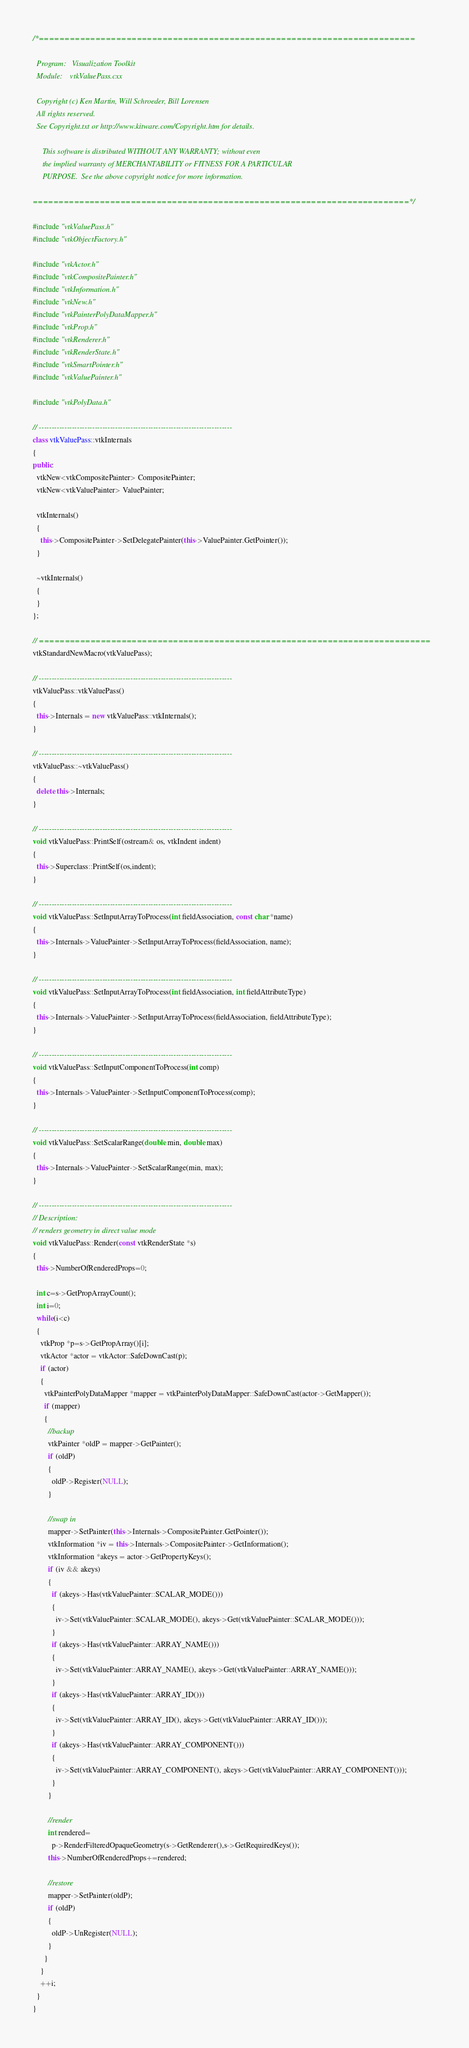<code> <loc_0><loc_0><loc_500><loc_500><_C++_>/*=========================================================================

  Program:   Visualization Toolkit
  Module:    vtkValuePass.cxx

  Copyright (c) Ken Martin, Will Schroeder, Bill Lorensen
  All rights reserved.
  See Copyright.txt or http://www.kitware.com/Copyright.htm for details.

     This software is distributed WITHOUT ANY WARRANTY; without even
     the implied warranty of MERCHANTABILITY or FITNESS FOR A PARTICULAR
     PURPOSE.  See the above copyright notice for more information.

=========================================================================*/

#include "vtkValuePass.h"
#include "vtkObjectFactory.h"

#include "vtkActor.h"
#include "vtkCompositePainter.h"
#include "vtkInformation.h"
#include "vtkNew.h"
#include "vtkPainterPolyDataMapper.h"
#include "vtkProp.h"
#include "vtkRenderer.h"
#include "vtkRenderState.h"
#include "vtkSmartPointer.h"
#include "vtkValuePainter.h"

#include "vtkPolyData.h"

// ----------------------------------------------------------------------------
class vtkValuePass::vtkInternals
{
public:
  vtkNew<vtkCompositePainter> CompositePainter;
  vtkNew<vtkValuePainter> ValuePainter;

  vtkInternals()
  {
    this->CompositePainter->SetDelegatePainter(this->ValuePainter.GetPointer());
  }

  ~vtkInternals()
  {
  }
};

// ============================================================================
vtkStandardNewMacro(vtkValuePass);

// ----------------------------------------------------------------------------
vtkValuePass::vtkValuePass()
{
  this->Internals = new vtkValuePass::vtkInternals();
}

// ----------------------------------------------------------------------------
vtkValuePass::~vtkValuePass()
{
  delete this->Internals;
}

// ----------------------------------------------------------------------------
void vtkValuePass::PrintSelf(ostream& os, vtkIndent indent)
{
  this->Superclass::PrintSelf(os,indent);
}

// ----------------------------------------------------------------------------
void vtkValuePass::SetInputArrayToProcess(int fieldAssociation, const char *name)
{
  this->Internals->ValuePainter->SetInputArrayToProcess(fieldAssociation, name);
}

// ----------------------------------------------------------------------------
void vtkValuePass::SetInputArrayToProcess(int fieldAssociation, int fieldAttributeType)
{
  this->Internals->ValuePainter->SetInputArrayToProcess(fieldAssociation, fieldAttributeType);
}

// ----------------------------------------------------------------------------
void vtkValuePass::SetInputComponentToProcess(int comp)
{
  this->Internals->ValuePainter->SetInputComponentToProcess(comp);
}

// ----------------------------------------------------------------------------
void vtkValuePass::SetScalarRange(double min, double max)
{
  this->Internals->ValuePainter->SetScalarRange(min, max);
}

// ----------------------------------------------------------------------------
// Description:
// renders geometry in direct value mode
void vtkValuePass::Render(const vtkRenderState *s)
{
  this->NumberOfRenderedProps=0;

  int c=s->GetPropArrayCount();
  int i=0;
  while(i<c)
  {
    vtkProp *p=s->GetPropArray()[i];
    vtkActor *actor = vtkActor::SafeDownCast(p);
    if (actor)
    {
      vtkPainterPolyDataMapper *mapper = vtkPainterPolyDataMapper::SafeDownCast(actor->GetMapper());
      if (mapper)
      {
        //backup
        vtkPainter *oldP = mapper->GetPainter();
        if (oldP)
        {
          oldP->Register(NULL);
        }

        //swap in
        mapper->SetPainter(this->Internals->CompositePainter.GetPointer());
        vtkInformation *iv = this->Internals->CompositePainter->GetInformation();
        vtkInformation *akeys = actor->GetPropertyKeys();
        if (iv && akeys)
        {
          if (akeys->Has(vtkValuePainter::SCALAR_MODE()))
          {
            iv->Set(vtkValuePainter::SCALAR_MODE(), akeys->Get(vtkValuePainter::SCALAR_MODE()));
          }
          if (akeys->Has(vtkValuePainter::ARRAY_NAME()))
          {
            iv->Set(vtkValuePainter::ARRAY_NAME(), akeys->Get(vtkValuePainter::ARRAY_NAME()));
          }
          if (akeys->Has(vtkValuePainter::ARRAY_ID()))
          {
            iv->Set(vtkValuePainter::ARRAY_ID(), akeys->Get(vtkValuePainter::ARRAY_ID()));
          }
          if (akeys->Has(vtkValuePainter::ARRAY_COMPONENT()))
          {
            iv->Set(vtkValuePainter::ARRAY_COMPONENT(), akeys->Get(vtkValuePainter::ARRAY_COMPONENT()));
          }
        }

        //render
        int rendered=
          p->RenderFilteredOpaqueGeometry(s->GetRenderer(),s->GetRequiredKeys());
        this->NumberOfRenderedProps+=rendered;

        //restore
        mapper->SetPainter(oldP);
        if (oldP)
        {
          oldP->UnRegister(NULL);
        }
      }
    }
    ++i;
  }
}
</code> 